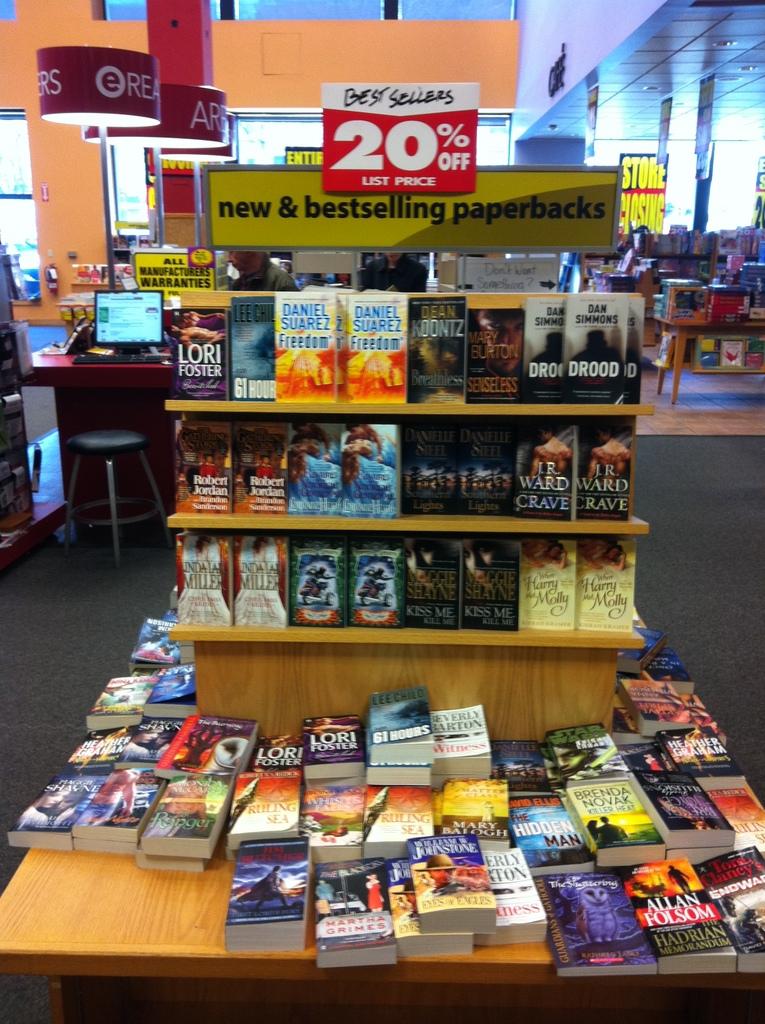What kind of books will you find in the section?
Keep it short and to the point. New & bestselling paperbacks. How much percent off are the books?
Provide a succinct answer. 20. 